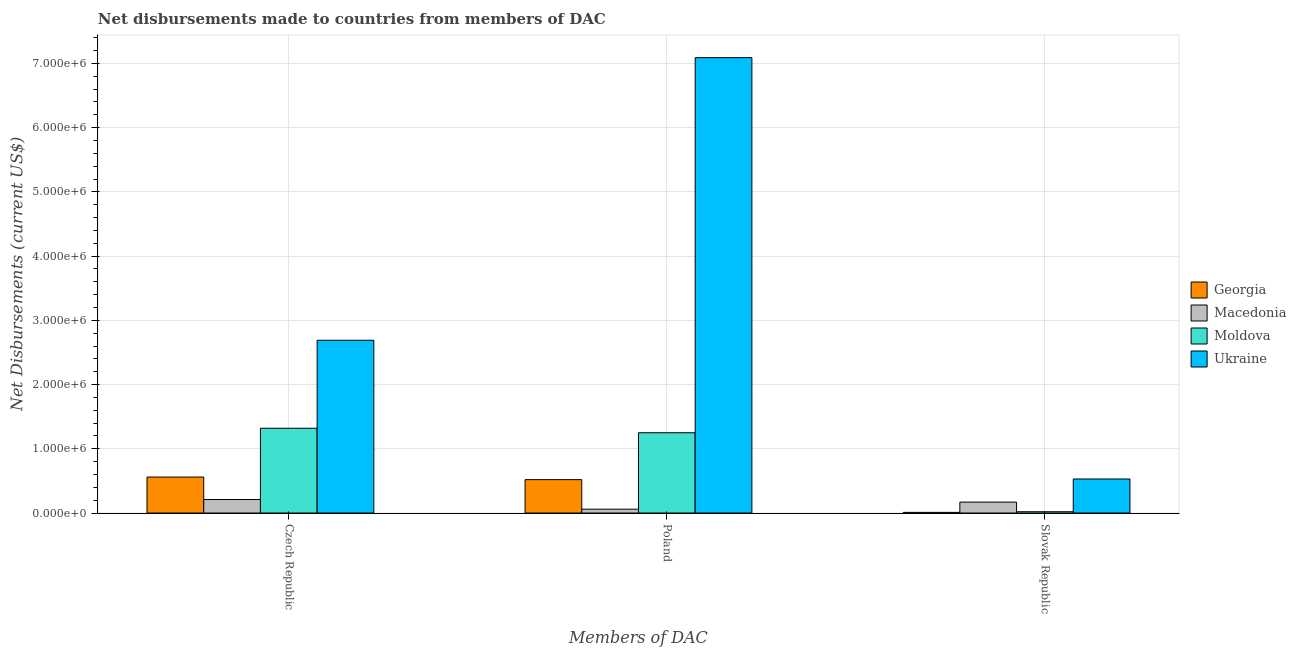How many different coloured bars are there?
Offer a terse response. 4. How many groups of bars are there?
Give a very brief answer. 3. Are the number of bars per tick equal to the number of legend labels?
Offer a very short reply. Yes. How many bars are there on the 3rd tick from the left?
Give a very brief answer. 4. What is the net disbursements made by poland in Macedonia?
Make the answer very short. 6.00e+04. Across all countries, what is the maximum net disbursements made by czech republic?
Make the answer very short. 2.69e+06. Across all countries, what is the minimum net disbursements made by slovak republic?
Ensure brevity in your answer.  10000. In which country was the net disbursements made by poland maximum?
Give a very brief answer. Ukraine. In which country was the net disbursements made by slovak republic minimum?
Your response must be concise. Georgia. What is the total net disbursements made by poland in the graph?
Offer a very short reply. 8.92e+06. What is the difference between the net disbursements made by slovak republic in Macedonia and that in Georgia?
Make the answer very short. 1.60e+05. What is the difference between the net disbursements made by czech republic in Moldova and the net disbursements made by poland in Macedonia?
Give a very brief answer. 1.26e+06. What is the average net disbursements made by slovak republic per country?
Provide a short and direct response. 1.82e+05. What is the difference between the net disbursements made by poland and net disbursements made by czech republic in Ukraine?
Your answer should be very brief. 4.40e+06. In how many countries, is the net disbursements made by czech republic greater than 2800000 US$?
Give a very brief answer. 0. What is the ratio of the net disbursements made by poland in Macedonia to that in Ukraine?
Provide a short and direct response. 0.01. Is the net disbursements made by slovak republic in Macedonia less than that in Georgia?
Your answer should be very brief. No. What is the difference between the highest and the second highest net disbursements made by poland?
Keep it short and to the point. 5.84e+06. What is the difference between the highest and the lowest net disbursements made by slovak republic?
Keep it short and to the point. 5.20e+05. Is the sum of the net disbursements made by poland in Georgia and Macedonia greater than the maximum net disbursements made by czech republic across all countries?
Keep it short and to the point. No. What does the 4th bar from the left in Poland represents?
Keep it short and to the point. Ukraine. What does the 2nd bar from the right in Slovak Republic represents?
Ensure brevity in your answer.  Moldova. Are all the bars in the graph horizontal?
Offer a very short reply. No. Are the values on the major ticks of Y-axis written in scientific E-notation?
Give a very brief answer. Yes. Does the graph contain any zero values?
Offer a very short reply. No. Does the graph contain grids?
Your answer should be compact. Yes. Where does the legend appear in the graph?
Your answer should be compact. Center right. How many legend labels are there?
Ensure brevity in your answer.  4. How are the legend labels stacked?
Keep it short and to the point. Vertical. What is the title of the graph?
Keep it short and to the point. Net disbursements made to countries from members of DAC. Does "Iran" appear as one of the legend labels in the graph?
Provide a short and direct response. No. What is the label or title of the X-axis?
Offer a very short reply. Members of DAC. What is the label or title of the Y-axis?
Ensure brevity in your answer.  Net Disbursements (current US$). What is the Net Disbursements (current US$) of Georgia in Czech Republic?
Make the answer very short. 5.60e+05. What is the Net Disbursements (current US$) of Moldova in Czech Republic?
Provide a short and direct response. 1.32e+06. What is the Net Disbursements (current US$) in Ukraine in Czech Republic?
Provide a succinct answer. 2.69e+06. What is the Net Disbursements (current US$) in Georgia in Poland?
Offer a terse response. 5.20e+05. What is the Net Disbursements (current US$) of Macedonia in Poland?
Your response must be concise. 6.00e+04. What is the Net Disbursements (current US$) of Moldova in Poland?
Provide a short and direct response. 1.25e+06. What is the Net Disbursements (current US$) in Ukraine in Poland?
Keep it short and to the point. 7.09e+06. What is the Net Disbursements (current US$) of Macedonia in Slovak Republic?
Keep it short and to the point. 1.70e+05. What is the Net Disbursements (current US$) of Moldova in Slovak Republic?
Ensure brevity in your answer.  2.00e+04. What is the Net Disbursements (current US$) in Ukraine in Slovak Republic?
Make the answer very short. 5.30e+05. Across all Members of DAC, what is the maximum Net Disbursements (current US$) of Georgia?
Make the answer very short. 5.60e+05. Across all Members of DAC, what is the maximum Net Disbursements (current US$) of Macedonia?
Keep it short and to the point. 2.10e+05. Across all Members of DAC, what is the maximum Net Disbursements (current US$) in Moldova?
Offer a very short reply. 1.32e+06. Across all Members of DAC, what is the maximum Net Disbursements (current US$) in Ukraine?
Your answer should be very brief. 7.09e+06. Across all Members of DAC, what is the minimum Net Disbursements (current US$) of Georgia?
Ensure brevity in your answer.  10000. Across all Members of DAC, what is the minimum Net Disbursements (current US$) in Moldova?
Ensure brevity in your answer.  2.00e+04. Across all Members of DAC, what is the minimum Net Disbursements (current US$) in Ukraine?
Your answer should be compact. 5.30e+05. What is the total Net Disbursements (current US$) in Georgia in the graph?
Your answer should be very brief. 1.09e+06. What is the total Net Disbursements (current US$) in Moldova in the graph?
Your answer should be very brief. 2.59e+06. What is the total Net Disbursements (current US$) in Ukraine in the graph?
Offer a terse response. 1.03e+07. What is the difference between the Net Disbursements (current US$) of Moldova in Czech Republic and that in Poland?
Give a very brief answer. 7.00e+04. What is the difference between the Net Disbursements (current US$) of Ukraine in Czech Republic and that in Poland?
Your answer should be very brief. -4.40e+06. What is the difference between the Net Disbursements (current US$) in Georgia in Czech Republic and that in Slovak Republic?
Offer a very short reply. 5.50e+05. What is the difference between the Net Disbursements (current US$) of Macedonia in Czech Republic and that in Slovak Republic?
Keep it short and to the point. 4.00e+04. What is the difference between the Net Disbursements (current US$) in Moldova in Czech Republic and that in Slovak Republic?
Keep it short and to the point. 1.30e+06. What is the difference between the Net Disbursements (current US$) in Ukraine in Czech Republic and that in Slovak Republic?
Provide a short and direct response. 2.16e+06. What is the difference between the Net Disbursements (current US$) of Georgia in Poland and that in Slovak Republic?
Provide a succinct answer. 5.10e+05. What is the difference between the Net Disbursements (current US$) of Macedonia in Poland and that in Slovak Republic?
Provide a succinct answer. -1.10e+05. What is the difference between the Net Disbursements (current US$) of Moldova in Poland and that in Slovak Republic?
Offer a very short reply. 1.23e+06. What is the difference between the Net Disbursements (current US$) of Ukraine in Poland and that in Slovak Republic?
Offer a terse response. 6.56e+06. What is the difference between the Net Disbursements (current US$) in Georgia in Czech Republic and the Net Disbursements (current US$) in Macedonia in Poland?
Your answer should be compact. 5.00e+05. What is the difference between the Net Disbursements (current US$) in Georgia in Czech Republic and the Net Disbursements (current US$) in Moldova in Poland?
Your response must be concise. -6.90e+05. What is the difference between the Net Disbursements (current US$) in Georgia in Czech Republic and the Net Disbursements (current US$) in Ukraine in Poland?
Your answer should be very brief. -6.53e+06. What is the difference between the Net Disbursements (current US$) of Macedonia in Czech Republic and the Net Disbursements (current US$) of Moldova in Poland?
Your answer should be compact. -1.04e+06. What is the difference between the Net Disbursements (current US$) in Macedonia in Czech Republic and the Net Disbursements (current US$) in Ukraine in Poland?
Your answer should be compact. -6.88e+06. What is the difference between the Net Disbursements (current US$) in Moldova in Czech Republic and the Net Disbursements (current US$) in Ukraine in Poland?
Ensure brevity in your answer.  -5.77e+06. What is the difference between the Net Disbursements (current US$) in Georgia in Czech Republic and the Net Disbursements (current US$) in Moldova in Slovak Republic?
Your answer should be compact. 5.40e+05. What is the difference between the Net Disbursements (current US$) in Georgia in Czech Republic and the Net Disbursements (current US$) in Ukraine in Slovak Republic?
Offer a terse response. 3.00e+04. What is the difference between the Net Disbursements (current US$) in Macedonia in Czech Republic and the Net Disbursements (current US$) in Ukraine in Slovak Republic?
Ensure brevity in your answer.  -3.20e+05. What is the difference between the Net Disbursements (current US$) of Moldova in Czech Republic and the Net Disbursements (current US$) of Ukraine in Slovak Republic?
Keep it short and to the point. 7.90e+05. What is the difference between the Net Disbursements (current US$) in Macedonia in Poland and the Net Disbursements (current US$) in Ukraine in Slovak Republic?
Give a very brief answer. -4.70e+05. What is the difference between the Net Disbursements (current US$) in Moldova in Poland and the Net Disbursements (current US$) in Ukraine in Slovak Republic?
Keep it short and to the point. 7.20e+05. What is the average Net Disbursements (current US$) in Georgia per Members of DAC?
Give a very brief answer. 3.63e+05. What is the average Net Disbursements (current US$) of Macedonia per Members of DAC?
Your response must be concise. 1.47e+05. What is the average Net Disbursements (current US$) in Moldova per Members of DAC?
Ensure brevity in your answer.  8.63e+05. What is the average Net Disbursements (current US$) in Ukraine per Members of DAC?
Your answer should be very brief. 3.44e+06. What is the difference between the Net Disbursements (current US$) of Georgia and Net Disbursements (current US$) of Macedonia in Czech Republic?
Give a very brief answer. 3.50e+05. What is the difference between the Net Disbursements (current US$) in Georgia and Net Disbursements (current US$) in Moldova in Czech Republic?
Keep it short and to the point. -7.60e+05. What is the difference between the Net Disbursements (current US$) in Georgia and Net Disbursements (current US$) in Ukraine in Czech Republic?
Provide a succinct answer. -2.13e+06. What is the difference between the Net Disbursements (current US$) of Macedonia and Net Disbursements (current US$) of Moldova in Czech Republic?
Offer a terse response. -1.11e+06. What is the difference between the Net Disbursements (current US$) in Macedonia and Net Disbursements (current US$) in Ukraine in Czech Republic?
Provide a short and direct response. -2.48e+06. What is the difference between the Net Disbursements (current US$) in Moldova and Net Disbursements (current US$) in Ukraine in Czech Republic?
Ensure brevity in your answer.  -1.37e+06. What is the difference between the Net Disbursements (current US$) in Georgia and Net Disbursements (current US$) in Macedonia in Poland?
Offer a terse response. 4.60e+05. What is the difference between the Net Disbursements (current US$) of Georgia and Net Disbursements (current US$) of Moldova in Poland?
Your response must be concise. -7.30e+05. What is the difference between the Net Disbursements (current US$) in Georgia and Net Disbursements (current US$) in Ukraine in Poland?
Give a very brief answer. -6.57e+06. What is the difference between the Net Disbursements (current US$) in Macedonia and Net Disbursements (current US$) in Moldova in Poland?
Give a very brief answer. -1.19e+06. What is the difference between the Net Disbursements (current US$) in Macedonia and Net Disbursements (current US$) in Ukraine in Poland?
Your response must be concise. -7.03e+06. What is the difference between the Net Disbursements (current US$) of Moldova and Net Disbursements (current US$) of Ukraine in Poland?
Your response must be concise. -5.84e+06. What is the difference between the Net Disbursements (current US$) of Georgia and Net Disbursements (current US$) of Macedonia in Slovak Republic?
Keep it short and to the point. -1.60e+05. What is the difference between the Net Disbursements (current US$) in Georgia and Net Disbursements (current US$) in Moldova in Slovak Republic?
Keep it short and to the point. -10000. What is the difference between the Net Disbursements (current US$) of Georgia and Net Disbursements (current US$) of Ukraine in Slovak Republic?
Offer a terse response. -5.20e+05. What is the difference between the Net Disbursements (current US$) in Macedonia and Net Disbursements (current US$) in Ukraine in Slovak Republic?
Make the answer very short. -3.60e+05. What is the difference between the Net Disbursements (current US$) of Moldova and Net Disbursements (current US$) of Ukraine in Slovak Republic?
Ensure brevity in your answer.  -5.10e+05. What is the ratio of the Net Disbursements (current US$) of Macedonia in Czech Republic to that in Poland?
Keep it short and to the point. 3.5. What is the ratio of the Net Disbursements (current US$) of Moldova in Czech Republic to that in Poland?
Provide a short and direct response. 1.06. What is the ratio of the Net Disbursements (current US$) of Ukraine in Czech Republic to that in Poland?
Provide a succinct answer. 0.38. What is the ratio of the Net Disbursements (current US$) of Macedonia in Czech Republic to that in Slovak Republic?
Your answer should be compact. 1.24. What is the ratio of the Net Disbursements (current US$) of Moldova in Czech Republic to that in Slovak Republic?
Provide a short and direct response. 66. What is the ratio of the Net Disbursements (current US$) in Ukraine in Czech Republic to that in Slovak Republic?
Make the answer very short. 5.08. What is the ratio of the Net Disbursements (current US$) in Macedonia in Poland to that in Slovak Republic?
Ensure brevity in your answer.  0.35. What is the ratio of the Net Disbursements (current US$) in Moldova in Poland to that in Slovak Republic?
Keep it short and to the point. 62.5. What is the ratio of the Net Disbursements (current US$) of Ukraine in Poland to that in Slovak Republic?
Provide a succinct answer. 13.38. What is the difference between the highest and the second highest Net Disbursements (current US$) of Macedonia?
Make the answer very short. 4.00e+04. What is the difference between the highest and the second highest Net Disbursements (current US$) of Ukraine?
Keep it short and to the point. 4.40e+06. What is the difference between the highest and the lowest Net Disbursements (current US$) of Georgia?
Your answer should be very brief. 5.50e+05. What is the difference between the highest and the lowest Net Disbursements (current US$) of Moldova?
Keep it short and to the point. 1.30e+06. What is the difference between the highest and the lowest Net Disbursements (current US$) of Ukraine?
Provide a succinct answer. 6.56e+06. 